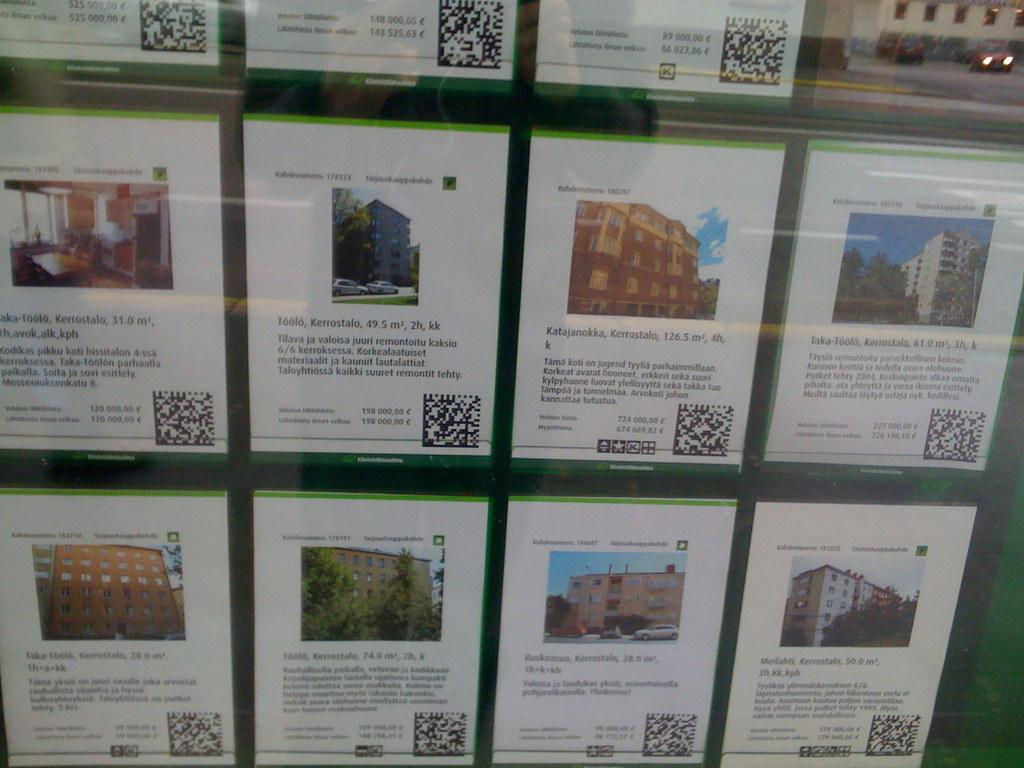<image>
Provide a brief description of the given image. A display of home information on a screen, the top one lists price as 500,000 